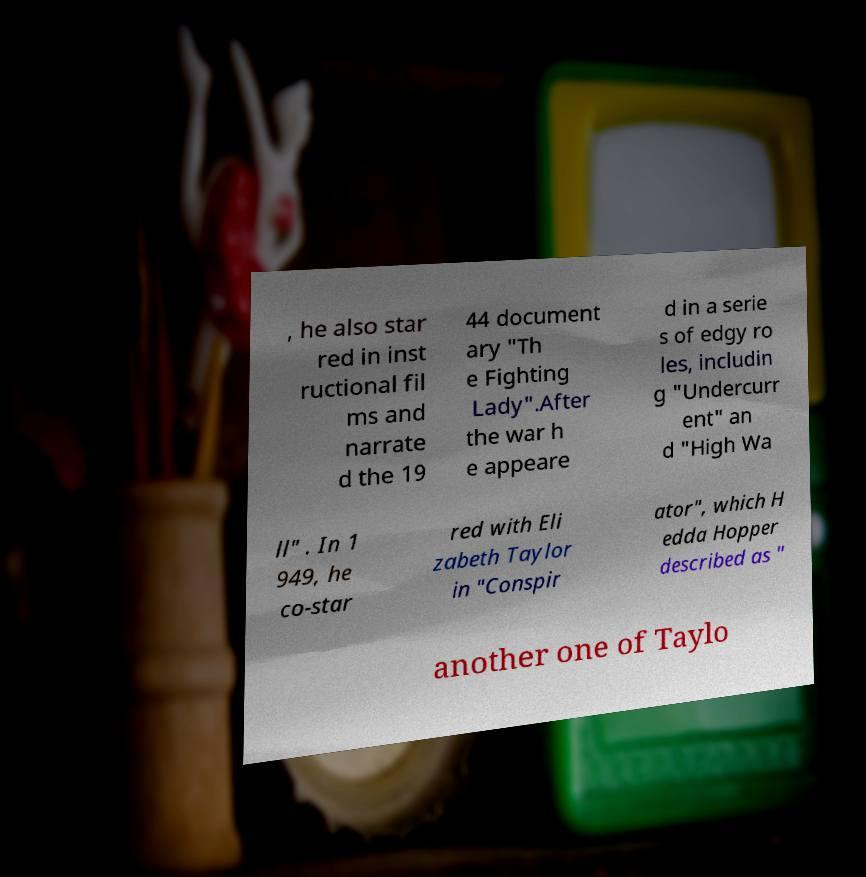What messages or text are displayed in this image? I need them in a readable, typed format. , he also star red in inst ructional fil ms and narrate d the 19 44 document ary "Th e Fighting Lady".After the war h e appeare d in a serie s of edgy ro les, includin g "Undercurr ent" an d "High Wa ll" . In 1 949, he co-star red with Eli zabeth Taylor in "Conspir ator", which H edda Hopper described as " another one of Taylo 